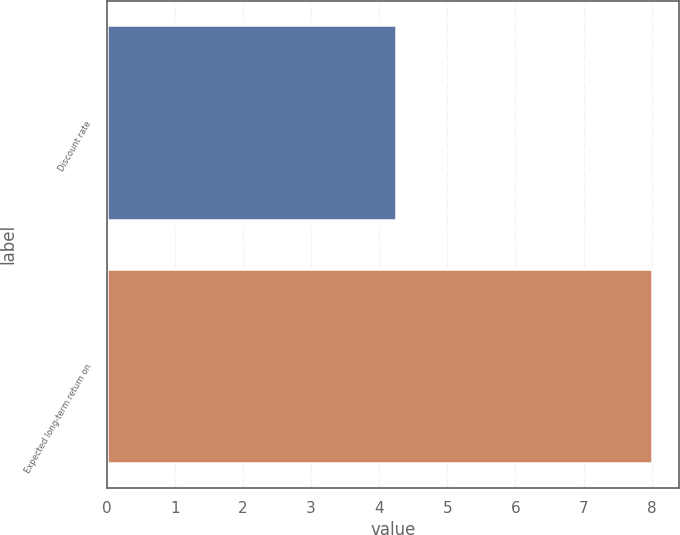Convert chart to OTSL. <chart><loc_0><loc_0><loc_500><loc_500><bar_chart><fcel>Discount rate<fcel>Expected long-term return on<nl><fcel>4.25<fcel>8<nl></chart> 